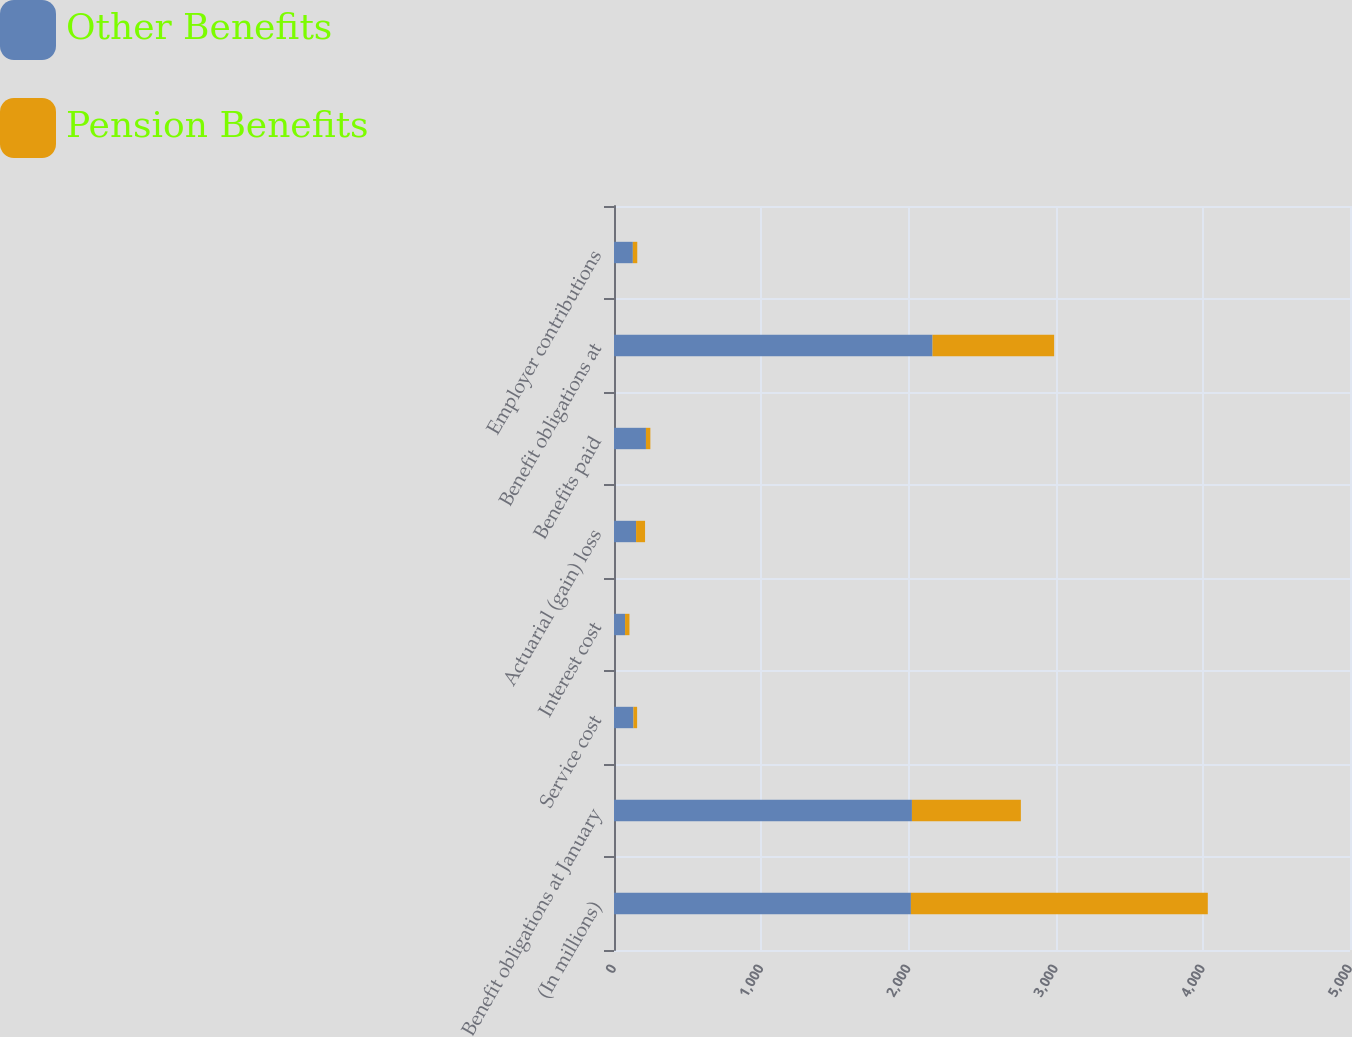Convert chart. <chart><loc_0><loc_0><loc_500><loc_500><stacked_bar_chart><ecel><fcel>(In millions)<fcel>Benefit obligations at January<fcel>Service cost<fcel>Interest cost<fcel>Actuarial (gain) loss<fcel>Benefits paid<fcel>Benefit obligations at<fcel>Employer contributions<nl><fcel>Other Benefits<fcel>2017<fcel>2024<fcel>132<fcel>75<fcel>150<fcel>217<fcel>2164<fcel>128<nl><fcel>Pension Benefits<fcel>2017<fcel>740<fcel>25<fcel>30<fcel>61<fcel>30<fcel>826<fcel>30<nl></chart> 